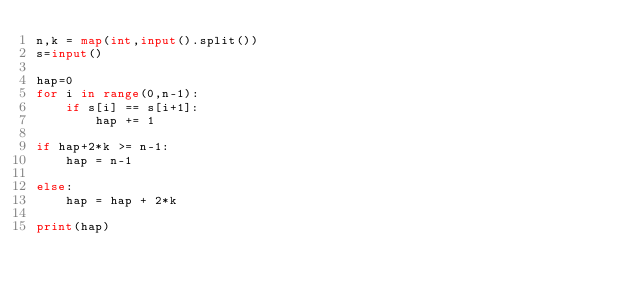<code> <loc_0><loc_0><loc_500><loc_500><_Python_>n,k = map(int,input().split())
s=input()

hap=0
for i in range(0,n-1):
    if s[i] == s[i+1]:
        hap += 1

if hap+2*k >= n-1:
    hap = n-1

else:
    hap = hap + 2*k

print(hap)</code> 